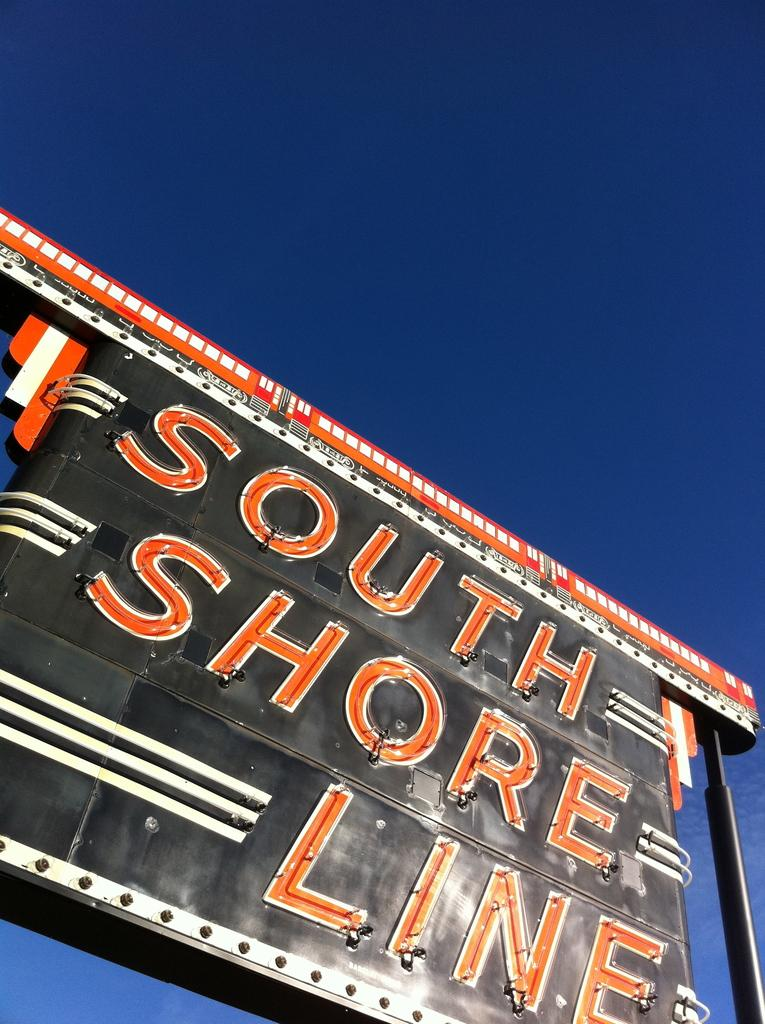<image>
Offer a succinct explanation of the picture presented. A large outdoor billboard with the name South Shore Line on it. 